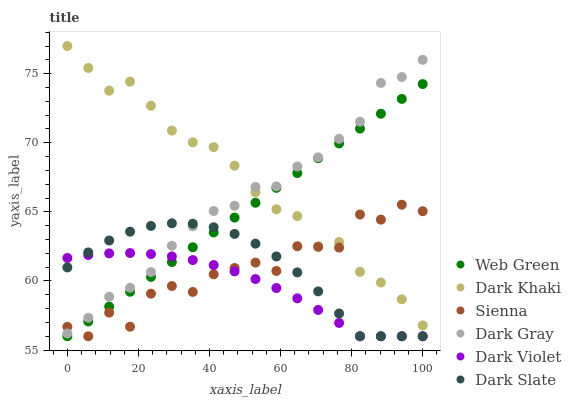Does Dark Violet have the minimum area under the curve?
Answer yes or no. Yes. Does Dark Khaki have the maximum area under the curve?
Answer yes or no. Yes. Does Dark Khaki have the minimum area under the curve?
Answer yes or no. No. Does Dark Violet have the maximum area under the curve?
Answer yes or no. No. Is Web Green the smoothest?
Answer yes or no. Yes. Is Sienna the roughest?
Answer yes or no. Yes. Is Dark Violet the smoothest?
Answer yes or no. No. Is Dark Violet the roughest?
Answer yes or no. No. Does Sienna have the lowest value?
Answer yes or no. Yes. Does Dark Khaki have the lowest value?
Answer yes or no. No. Does Dark Khaki have the highest value?
Answer yes or no. Yes. Does Dark Violet have the highest value?
Answer yes or no. No. Is Web Green less than Dark Gray?
Answer yes or no. Yes. Is Dark Khaki greater than Dark Slate?
Answer yes or no. Yes. Does Dark Slate intersect Dark Gray?
Answer yes or no. Yes. Is Dark Slate less than Dark Gray?
Answer yes or no. No. Is Dark Slate greater than Dark Gray?
Answer yes or no. No. Does Web Green intersect Dark Gray?
Answer yes or no. No. 